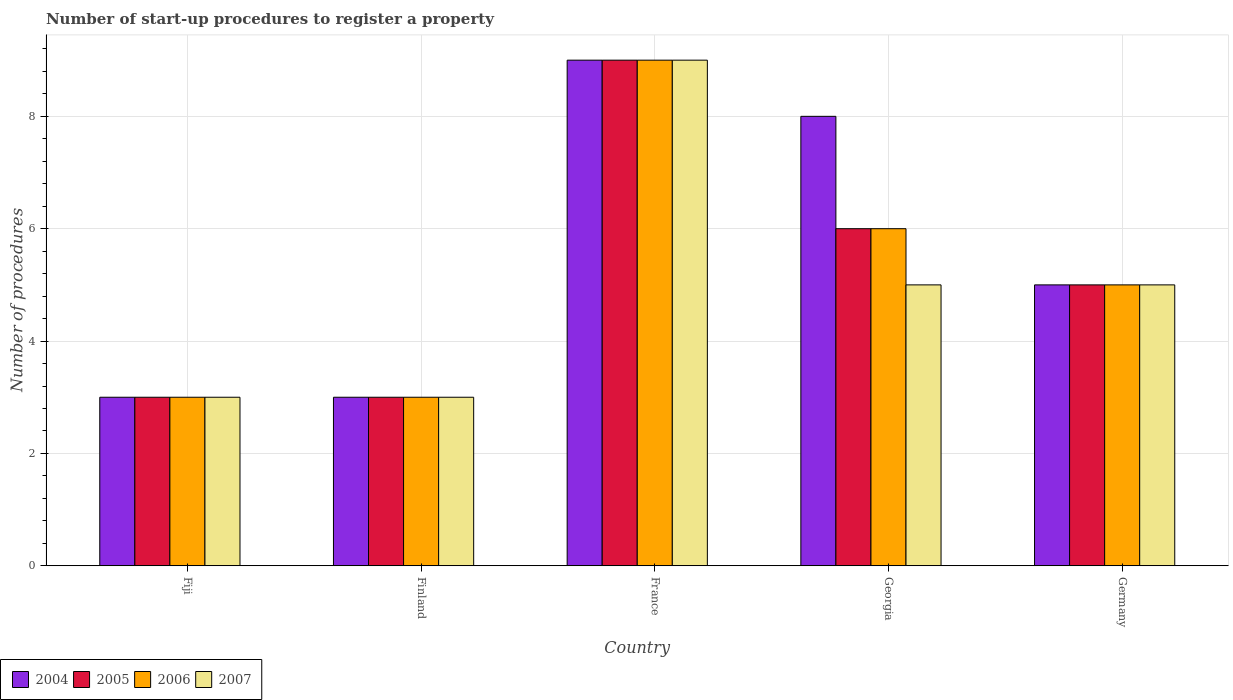Are the number of bars on each tick of the X-axis equal?
Ensure brevity in your answer.  Yes. How many bars are there on the 3rd tick from the left?
Provide a short and direct response. 4. What is the label of the 1st group of bars from the left?
Your response must be concise. Fiji. Across all countries, what is the minimum number of procedures required to register a property in 2005?
Your answer should be very brief. 3. In which country was the number of procedures required to register a property in 2005 minimum?
Keep it short and to the point. Fiji. What is the difference between the number of procedures required to register a property of/in 2006 and number of procedures required to register a property of/in 2005 in Fiji?
Give a very brief answer. 0. Is the number of procedures required to register a property in 2007 in France less than that in Germany?
Provide a succinct answer. No. Is the difference between the number of procedures required to register a property in 2006 in Georgia and Germany greater than the difference between the number of procedures required to register a property in 2005 in Georgia and Germany?
Make the answer very short. No. What is the difference between the highest and the lowest number of procedures required to register a property in 2007?
Your answer should be very brief. 6. What does the 1st bar from the right in France represents?
Ensure brevity in your answer.  2007. Is it the case that in every country, the sum of the number of procedures required to register a property in 2005 and number of procedures required to register a property in 2006 is greater than the number of procedures required to register a property in 2004?
Offer a terse response. Yes. How many countries are there in the graph?
Offer a very short reply. 5. What is the difference between two consecutive major ticks on the Y-axis?
Make the answer very short. 2. Are the values on the major ticks of Y-axis written in scientific E-notation?
Your answer should be very brief. No. Does the graph contain any zero values?
Offer a very short reply. No. Where does the legend appear in the graph?
Offer a terse response. Bottom left. What is the title of the graph?
Your answer should be very brief. Number of start-up procedures to register a property. What is the label or title of the X-axis?
Give a very brief answer. Country. What is the label or title of the Y-axis?
Your response must be concise. Number of procedures. What is the Number of procedures of 2004 in Fiji?
Provide a short and direct response. 3. What is the Number of procedures of 2006 in Fiji?
Keep it short and to the point. 3. What is the Number of procedures in 2004 in Finland?
Ensure brevity in your answer.  3. What is the Number of procedures in 2005 in Finland?
Your answer should be very brief. 3. What is the Number of procedures of 2006 in Finland?
Provide a short and direct response. 3. What is the Number of procedures of 2006 in France?
Ensure brevity in your answer.  9. What is the Number of procedures of 2007 in France?
Your answer should be compact. 9. What is the Number of procedures in 2004 in Georgia?
Provide a short and direct response. 8. What is the Number of procedures in 2005 in Georgia?
Provide a succinct answer. 6. What is the Number of procedures in 2006 in Georgia?
Offer a very short reply. 6. What is the Number of procedures of 2007 in Georgia?
Provide a succinct answer. 5. Across all countries, what is the maximum Number of procedures in 2004?
Provide a short and direct response. 9. Across all countries, what is the maximum Number of procedures in 2006?
Provide a succinct answer. 9. Across all countries, what is the maximum Number of procedures of 2007?
Your response must be concise. 9. Across all countries, what is the minimum Number of procedures of 2005?
Offer a very short reply. 3. Across all countries, what is the minimum Number of procedures of 2007?
Make the answer very short. 3. What is the total Number of procedures in 2005 in the graph?
Ensure brevity in your answer.  26. What is the total Number of procedures of 2006 in the graph?
Ensure brevity in your answer.  26. What is the difference between the Number of procedures of 2004 in Fiji and that in France?
Make the answer very short. -6. What is the difference between the Number of procedures in 2006 in Fiji and that in France?
Your response must be concise. -6. What is the difference between the Number of procedures of 2005 in Fiji and that in Georgia?
Your response must be concise. -3. What is the difference between the Number of procedures of 2007 in Fiji and that in Georgia?
Offer a terse response. -2. What is the difference between the Number of procedures in 2004 in Fiji and that in Germany?
Your answer should be very brief. -2. What is the difference between the Number of procedures in 2005 in Fiji and that in Germany?
Offer a very short reply. -2. What is the difference between the Number of procedures in 2006 in Fiji and that in Germany?
Provide a succinct answer. -2. What is the difference between the Number of procedures of 2004 in Finland and that in France?
Keep it short and to the point. -6. What is the difference between the Number of procedures in 2006 in Finland and that in France?
Give a very brief answer. -6. What is the difference between the Number of procedures in 2007 in Finland and that in France?
Provide a short and direct response. -6. What is the difference between the Number of procedures in 2004 in Finland and that in Georgia?
Offer a very short reply. -5. What is the difference between the Number of procedures of 2006 in Finland and that in Georgia?
Provide a succinct answer. -3. What is the difference between the Number of procedures in 2007 in Finland and that in Georgia?
Your answer should be compact. -2. What is the difference between the Number of procedures in 2004 in Finland and that in Germany?
Keep it short and to the point. -2. What is the difference between the Number of procedures of 2004 in France and that in Georgia?
Your answer should be very brief. 1. What is the difference between the Number of procedures of 2005 in France and that in Georgia?
Offer a terse response. 3. What is the difference between the Number of procedures in 2006 in France and that in Georgia?
Ensure brevity in your answer.  3. What is the difference between the Number of procedures of 2007 in France and that in Georgia?
Provide a succinct answer. 4. What is the difference between the Number of procedures of 2004 in Fiji and the Number of procedures of 2005 in Finland?
Ensure brevity in your answer.  0. What is the difference between the Number of procedures of 2004 in Fiji and the Number of procedures of 2006 in Finland?
Your response must be concise. 0. What is the difference between the Number of procedures in 2006 in Fiji and the Number of procedures in 2007 in Finland?
Give a very brief answer. 0. What is the difference between the Number of procedures in 2004 in Fiji and the Number of procedures in 2005 in France?
Make the answer very short. -6. What is the difference between the Number of procedures in 2004 in Fiji and the Number of procedures in 2006 in France?
Your response must be concise. -6. What is the difference between the Number of procedures of 2005 in Fiji and the Number of procedures of 2006 in France?
Your response must be concise. -6. What is the difference between the Number of procedures of 2006 in Fiji and the Number of procedures of 2007 in France?
Provide a succinct answer. -6. What is the difference between the Number of procedures in 2004 in Fiji and the Number of procedures in 2005 in Georgia?
Offer a terse response. -3. What is the difference between the Number of procedures in 2004 in Fiji and the Number of procedures in 2006 in Georgia?
Your answer should be compact. -3. What is the difference between the Number of procedures of 2004 in Fiji and the Number of procedures of 2007 in Georgia?
Give a very brief answer. -2. What is the difference between the Number of procedures in 2004 in Fiji and the Number of procedures in 2007 in Germany?
Provide a short and direct response. -2. What is the difference between the Number of procedures in 2006 in Fiji and the Number of procedures in 2007 in Germany?
Your answer should be very brief. -2. What is the difference between the Number of procedures in 2004 in Finland and the Number of procedures in 2006 in France?
Your answer should be compact. -6. What is the difference between the Number of procedures of 2005 in Finland and the Number of procedures of 2006 in France?
Provide a succinct answer. -6. What is the difference between the Number of procedures in 2005 in Finland and the Number of procedures in 2007 in France?
Keep it short and to the point. -6. What is the difference between the Number of procedures of 2006 in Finland and the Number of procedures of 2007 in France?
Ensure brevity in your answer.  -6. What is the difference between the Number of procedures in 2004 in Finland and the Number of procedures in 2006 in Georgia?
Your response must be concise. -3. What is the difference between the Number of procedures in 2005 in Finland and the Number of procedures in 2006 in Georgia?
Ensure brevity in your answer.  -3. What is the difference between the Number of procedures of 2006 in Finland and the Number of procedures of 2007 in Georgia?
Offer a very short reply. -2. What is the difference between the Number of procedures in 2004 in Finland and the Number of procedures in 2005 in Germany?
Offer a very short reply. -2. What is the difference between the Number of procedures in 2005 in Finland and the Number of procedures in 2006 in Germany?
Ensure brevity in your answer.  -2. What is the difference between the Number of procedures in 2005 in France and the Number of procedures in 2007 in Georgia?
Ensure brevity in your answer.  4. What is the difference between the Number of procedures in 2005 in France and the Number of procedures in 2006 in Germany?
Give a very brief answer. 4. What is the difference between the Number of procedures of 2005 in France and the Number of procedures of 2007 in Germany?
Provide a short and direct response. 4. What is the difference between the Number of procedures of 2004 in Georgia and the Number of procedures of 2006 in Germany?
Your answer should be compact. 3. What is the difference between the Number of procedures in 2004 in Georgia and the Number of procedures in 2007 in Germany?
Ensure brevity in your answer.  3. What is the difference between the Number of procedures in 2006 in Georgia and the Number of procedures in 2007 in Germany?
Provide a succinct answer. 1. What is the average Number of procedures of 2005 per country?
Provide a succinct answer. 5.2. What is the average Number of procedures in 2006 per country?
Your response must be concise. 5.2. What is the average Number of procedures of 2007 per country?
Keep it short and to the point. 5. What is the difference between the Number of procedures of 2004 and Number of procedures of 2005 in Fiji?
Keep it short and to the point. 0. What is the difference between the Number of procedures of 2004 and Number of procedures of 2006 in Fiji?
Keep it short and to the point. 0. What is the difference between the Number of procedures of 2004 and Number of procedures of 2007 in Fiji?
Give a very brief answer. 0. What is the difference between the Number of procedures of 2005 and Number of procedures of 2006 in Fiji?
Your answer should be very brief. 0. What is the difference between the Number of procedures in 2005 and Number of procedures in 2007 in Fiji?
Make the answer very short. 0. What is the difference between the Number of procedures of 2006 and Number of procedures of 2007 in Fiji?
Your answer should be very brief. 0. What is the difference between the Number of procedures in 2004 and Number of procedures in 2005 in Finland?
Provide a short and direct response. 0. What is the difference between the Number of procedures of 2004 and Number of procedures of 2006 in Finland?
Your response must be concise. 0. What is the difference between the Number of procedures in 2006 and Number of procedures in 2007 in Finland?
Ensure brevity in your answer.  0. What is the difference between the Number of procedures of 2004 and Number of procedures of 2005 in France?
Your answer should be compact. 0. What is the difference between the Number of procedures in 2004 and Number of procedures in 2006 in France?
Offer a very short reply. 0. What is the difference between the Number of procedures in 2004 and Number of procedures in 2007 in France?
Ensure brevity in your answer.  0. What is the difference between the Number of procedures of 2005 and Number of procedures of 2007 in France?
Your answer should be very brief. 0. What is the difference between the Number of procedures of 2004 and Number of procedures of 2006 in Georgia?
Ensure brevity in your answer.  2. What is the difference between the Number of procedures in 2004 and Number of procedures in 2007 in Georgia?
Keep it short and to the point. 3. What is the difference between the Number of procedures in 2005 and Number of procedures in 2006 in Georgia?
Make the answer very short. 0. What is the difference between the Number of procedures of 2006 and Number of procedures of 2007 in Georgia?
Ensure brevity in your answer.  1. What is the difference between the Number of procedures in 2004 and Number of procedures in 2005 in Germany?
Ensure brevity in your answer.  0. What is the difference between the Number of procedures of 2004 and Number of procedures of 2007 in Germany?
Offer a terse response. 0. What is the ratio of the Number of procedures of 2006 in Fiji to that in Finland?
Provide a succinct answer. 1. What is the ratio of the Number of procedures in 2007 in Fiji to that in Finland?
Ensure brevity in your answer.  1. What is the ratio of the Number of procedures of 2004 in Fiji to that in France?
Your answer should be very brief. 0.33. What is the ratio of the Number of procedures of 2005 in Fiji to that in France?
Your answer should be very brief. 0.33. What is the ratio of the Number of procedures of 2006 in Fiji to that in France?
Keep it short and to the point. 0.33. What is the ratio of the Number of procedures in 2004 in Fiji to that in Georgia?
Your response must be concise. 0.38. What is the ratio of the Number of procedures of 2007 in Fiji to that in Germany?
Provide a short and direct response. 0.6. What is the ratio of the Number of procedures in 2005 in Finland to that in France?
Provide a short and direct response. 0.33. What is the ratio of the Number of procedures of 2007 in Finland to that in Georgia?
Offer a terse response. 0.6. What is the ratio of the Number of procedures in 2004 in Finland to that in Germany?
Your answer should be compact. 0.6. What is the ratio of the Number of procedures in 2005 in Finland to that in Germany?
Offer a terse response. 0.6. What is the ratio of the Number of procedures in 2006 in Finland to that in Germany?
Keep it short and to the point. 0.6. What is the ratio of the Number of procedures in 2006 in France to that in Georgia?
Provide a short and direct response. 1.5. What is the ratio of the Number of procedures of 2007 in France to that in Georgia?
Your answer should be very brief. 1.8. What is the difference between the highest and the second highest Number of procedures in 2004?
Your response must be concise. 1. What is the difference between the highest and the second highest Number of procedures of 2005?
Give a very brief answer. 3. What is the difference between the highest and the second highest Number of procedures in 2007?
Your response must be concise. 4. What is the difference between the highest and the lowest Number of procedures of 2005?
Your answer should be very brief. 6. What is the difference between the highest and the lowest Number of procedures of 2006?
Your response must be concise. 6. 